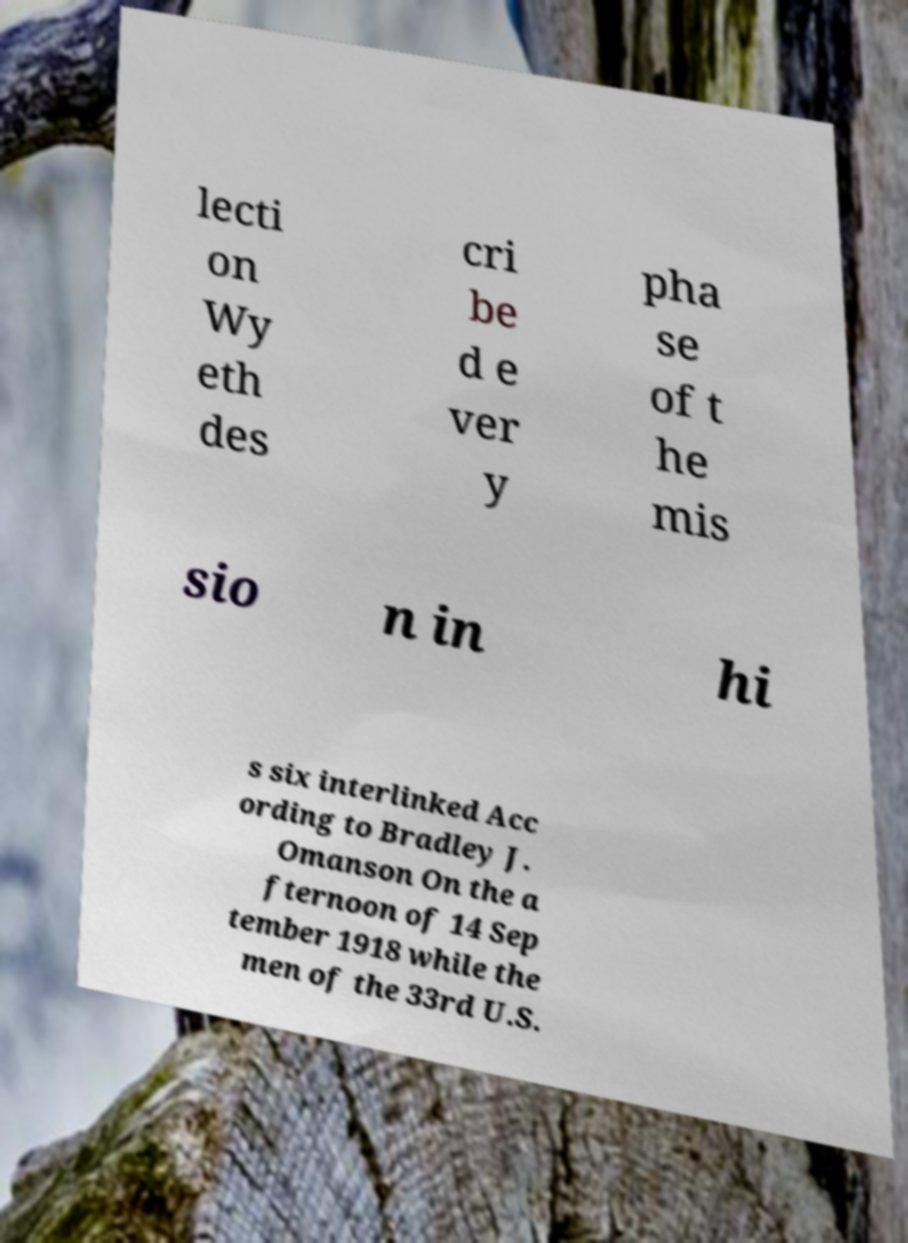Please identify and transcribe the text found in this image. lecti on Wy eth des cri be d e ver y pha se of t he mis sio n in hi s six interlinked Acc ording to Bradley J. Omanson On the a fternoon of 14 Sep tember 1918 while the men of the 33rd U.S. 